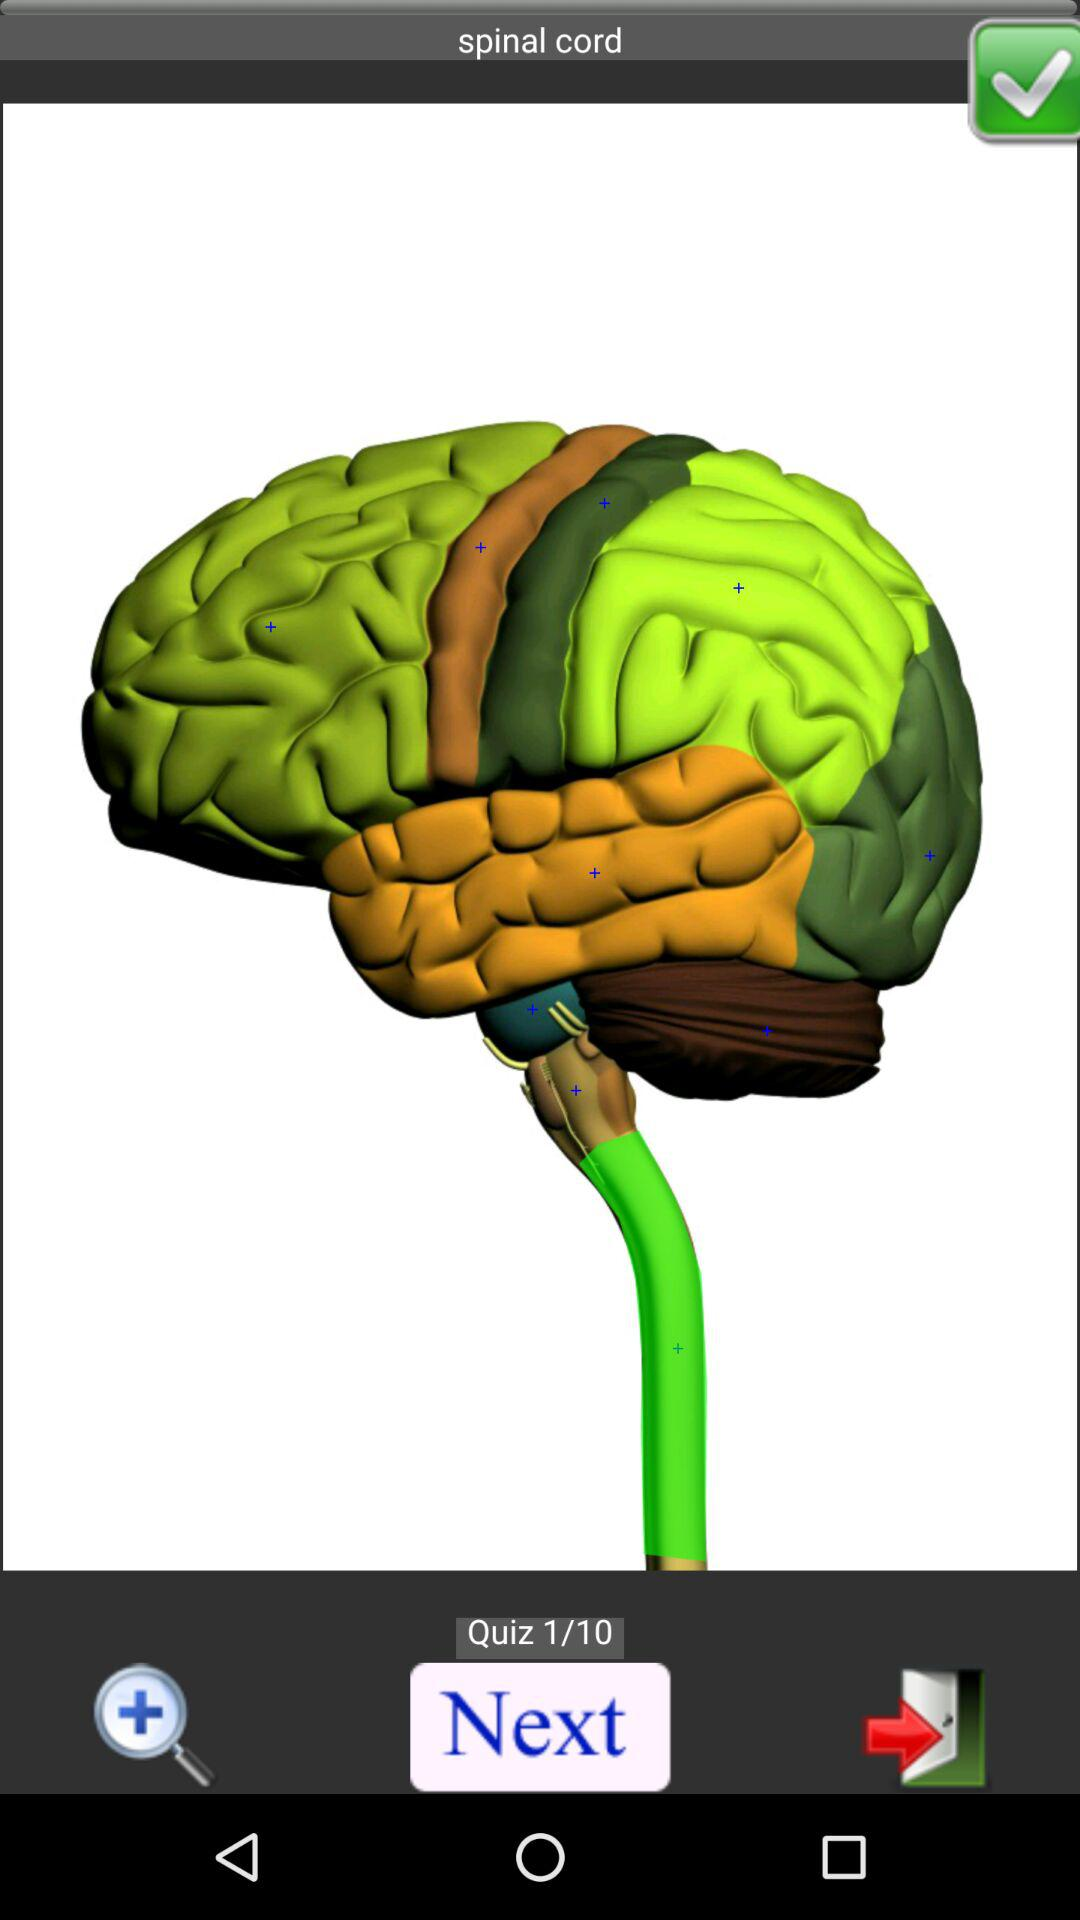How many quizzes in total are there? There are 10 quizzes in total. 